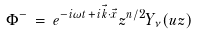Convert formula to latex. <formula><loc_0><loc_0><loc_500><loc_500>\Phi ^ { - } \, = \, e ^ { - i \omega t \, + \, i \vec { k } \cdot \vec { x } } z ^ { n / 2 } Y _ { \nu } ( u z )</formula> 